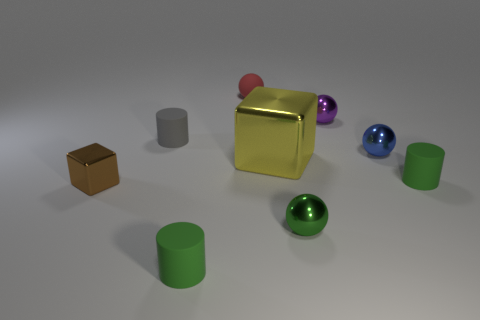What shape is the green matte object that is left of the tiny sphere in front of the tiny brown cube?
Offer a terse response. Cylinder. Are there any other things that have the same shape as the brown metal thing?
Offer a terse response. Yes. There is another metal object that is the same shape as the brown shiny thing; what is its color?
Keep it short and to the point. Yellow. There is a thing that is on the left side of the tiny green metallic sphere and in front of the small block; what is its shape?
Your answer should be compact. Cylinder. Is the number of rubber spheres less than the number of small cylinders?
Your answer should be very brief. Yes. Is there a large shiny thing?
Ensure brevity in your answer.  Yes. What number of other things are there of the same size as the blue shiny sphere?
Your response must be concise. 7. Does the yellow object have the same material as the sphere that is in front of the large yellow metal object?
Ensure brevity in your answer.  Yes. Are there an equal number of green objects to the left of the big thing and blocks in front of the small green ball?
Provide a short and direct response. No. What material is the small purple ball?
Your answer should be very brief. Metal. 